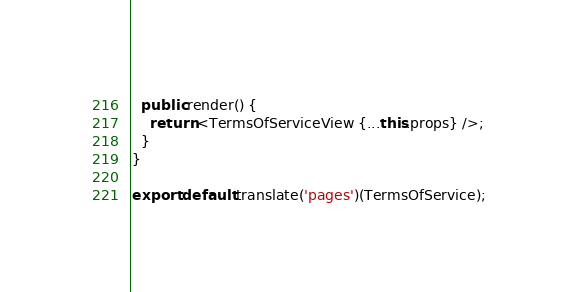Convert code to text. <code><loc_0><loc_0><loc_500><loc_500><_TypeScript_>  public render() {
    return <TermsOfServiceView {...this.props} />;
  }
}

export default translate('pages')(TermsOfService);
</code> 